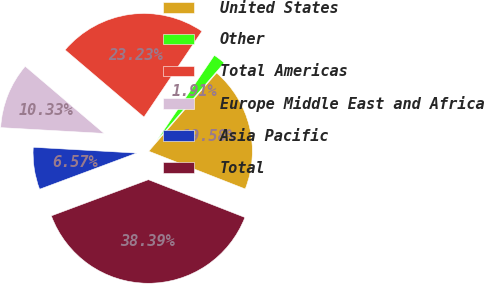<chart> <loc_0><loc_0><loc_500><loc_500><pie_chart><fcel>United States<fcel>Other<fcel>Total Americas<fcel>Europe Middle East and Africa<fcel>Asia Pacific<fcel>Total<nl><fcel>19.58%<fcel>1.91%<fcel>23.23%<fcel>10.33%<fcel>6.57%<fcel>38.39%<nl></chart> 